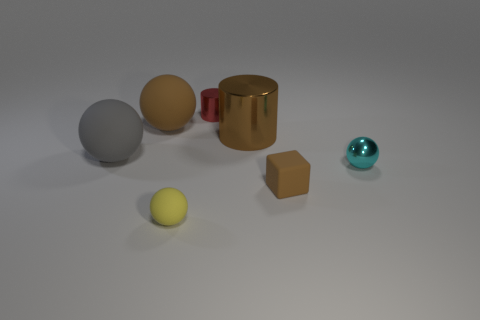Subtract all small metal spheres. How many spheres are left? 3 Subtract all gray balls. How many balls are left? 3 Subtract all balls. How many objects are left? 3 Add 2 small yellow rubber objects. How many objects exist? 9 Subtract 1 spheres. How many spheres are left? 3 Subtract all cyan balls. How many red cylinders are left? 1 Add 1 small cylinders. How many small cylinders exist? 2 Subtract 0 green balls. How many objects are left? 7 Subtract all green cubes. Subtract all yellow spheres. How many cubes are left? 1 Subtract all metallic objects. Subtract all large blue cylinders. How many objects are left? 4 